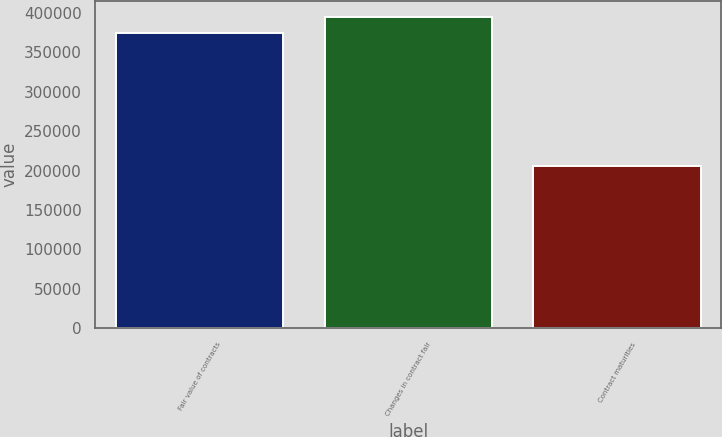Convert chart to OTSL. <chart><loc_0><loc_0><loc_500><loc_500><bar_chart><fcel>Fair value of contracts<fcel>Changes in contract fair<fcel>Contract maturities<nl><fcel>374099<fcel>394862<fcel>205882<nl></chart> 